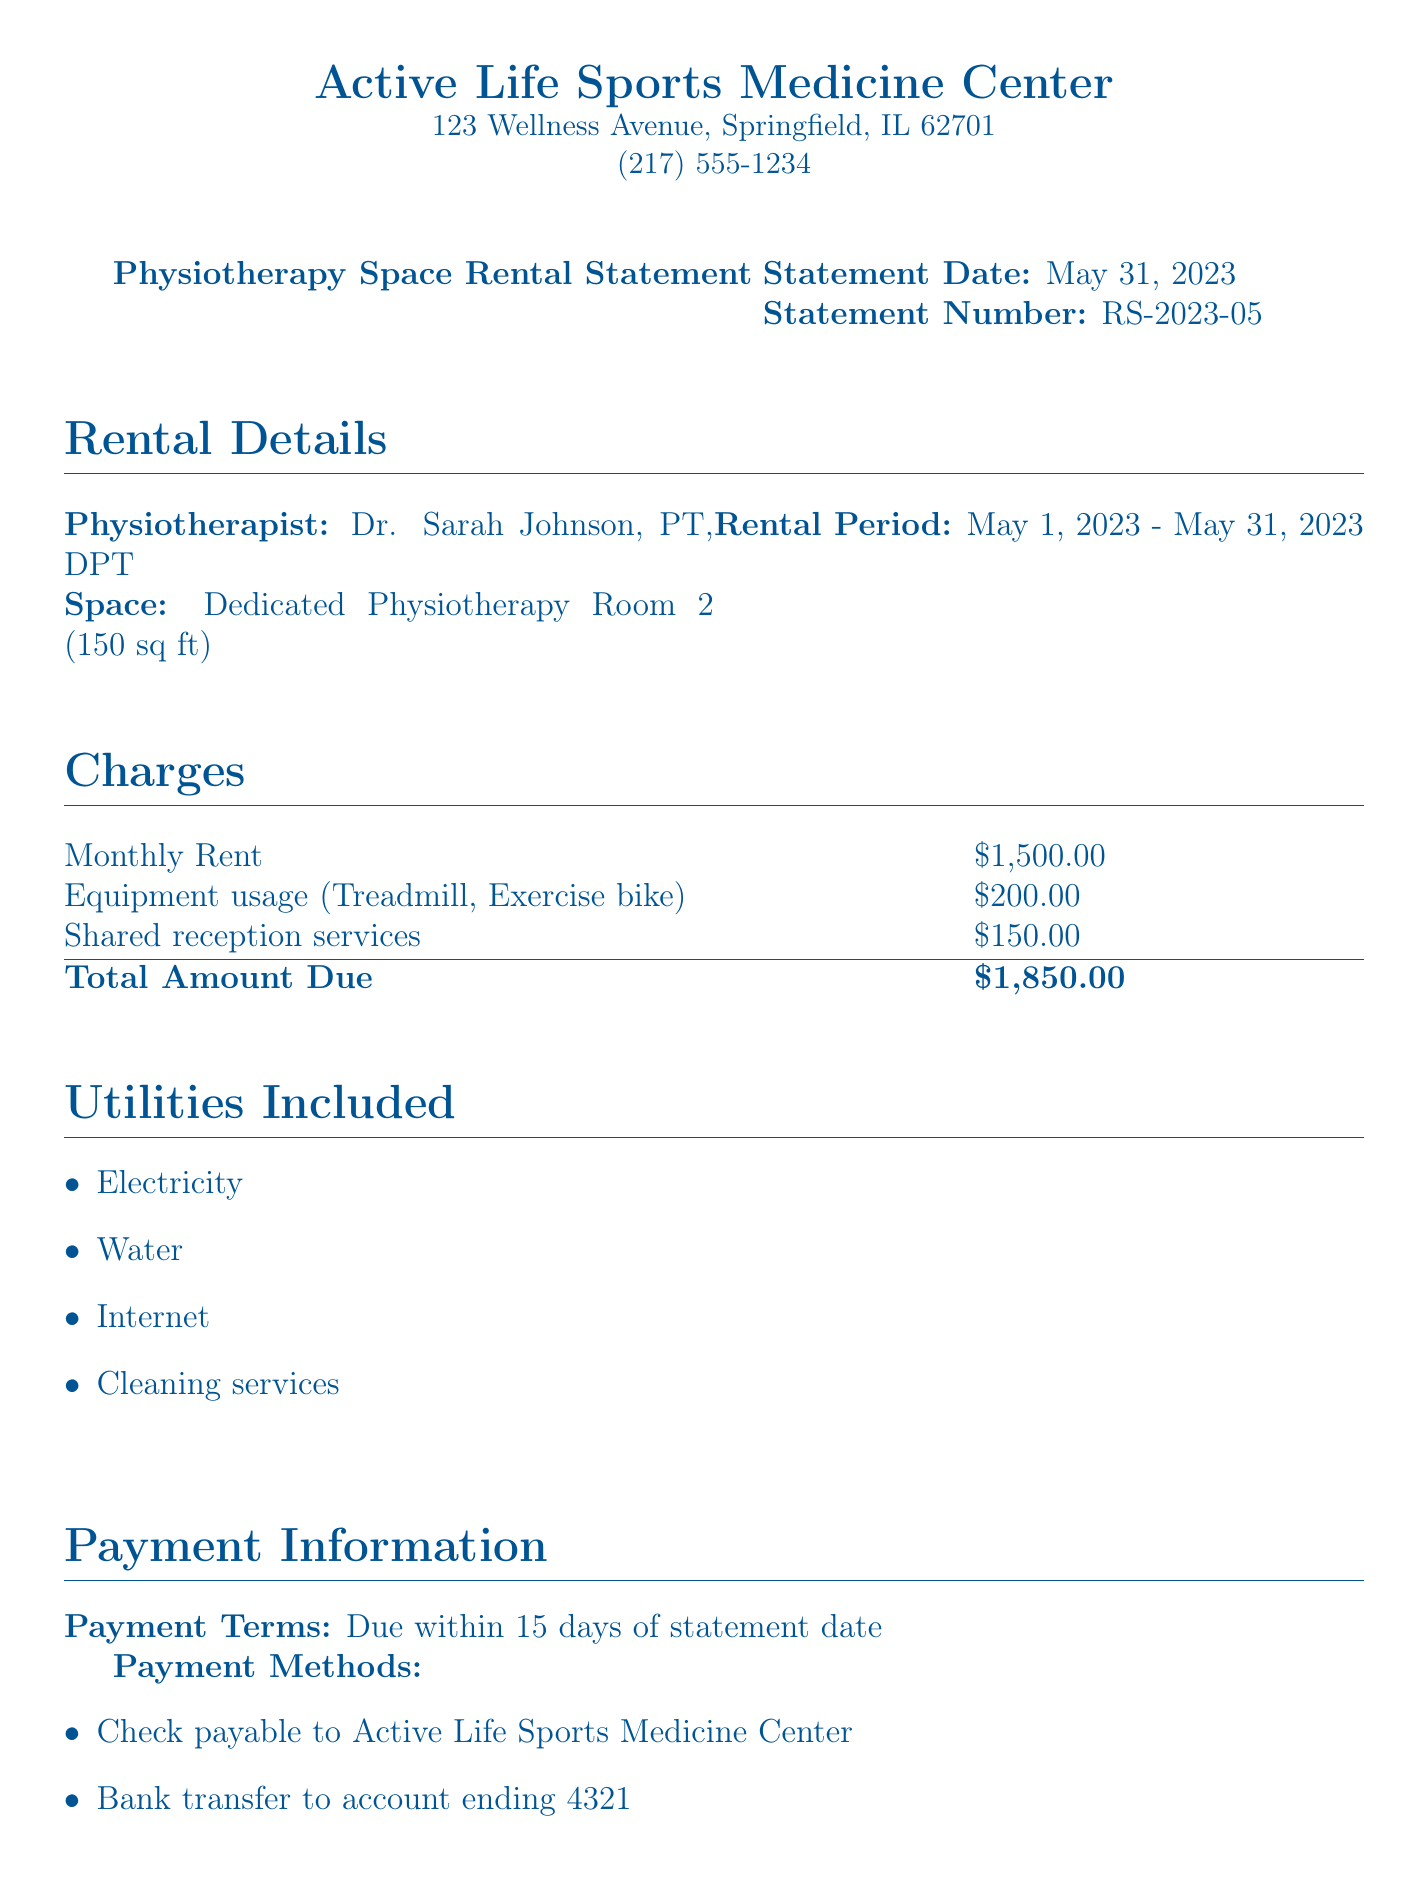What is the total amount due? The total amount due is mentioned in the charges section, which is the sum of the monthly rent, equipment usage, and shared reception services.
Answer: $1,850.00 Who is the physiotherapist? The name of the physiotherapist is listed in the rental details section.
Answer: Dr. Sarah Johnson, PT, DPT What is the rental period? The rental period indicates the timeframe during which the physiotherapy space was rented, stated in the rental details.
Answer: May 1, 2023 - May 31, 2023 What services are included in the utilities? The utilities section mentions the services that are included with the rental.
Answer: Electricity, Water, Internet, Cleaning services What are the payment terms? The payment terms specify the time frame for payment after the statement date.
Answer: Due within 15 days of statement date What is the equipment usage charge? The fee listed for equipment usage in the charges section specifies the cost associated with utilizing certain equipment.
Answer: $200.00 What is the dedicated physiotherapy room size? The size of the dedicated physiotherapy room is given in the rental details.
Answer: 150 sq ft Who is the referral doctor? The name of the referral doctor can be found at the bottom of the document in the signature section.
Answer: Dr. Michael Thompson, MD 